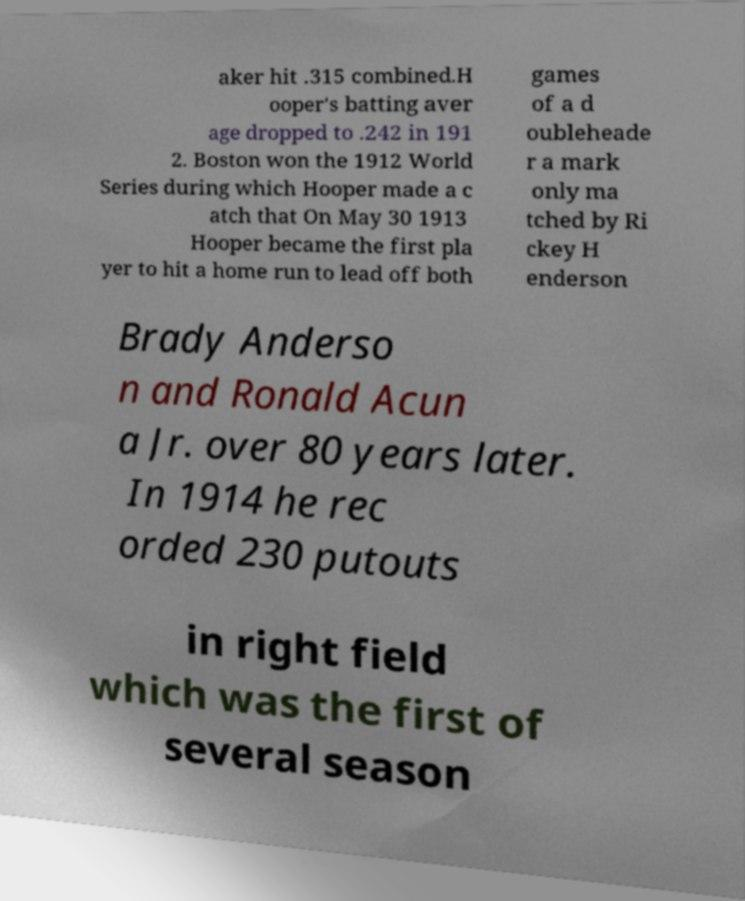Please read and relay the text visible in this image. What does it say? aker hit .315 combined.H ooper's batting aver age dropped to .242 in 191 2. Boston won the 1912 World Series during which Hooper made a c atch that On May 30 1913 Hooper became the first pla yer to hit a home run to lead off both games of a d oubleheade r a mark only ma tched by Ri ckey H enderson Brady Anderso n and Ronald Acun a Jr. over 80 years later. In 1914 he rec orded 230 putouts in right field which was the first of several season 